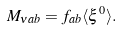Convert formula to latex. <formula><loc_0><loc_0><loc_500><loc_500>M _ { \nu a b } = f _ { a b } \langle \xi ^ { 0 } \rangle .</formula> 